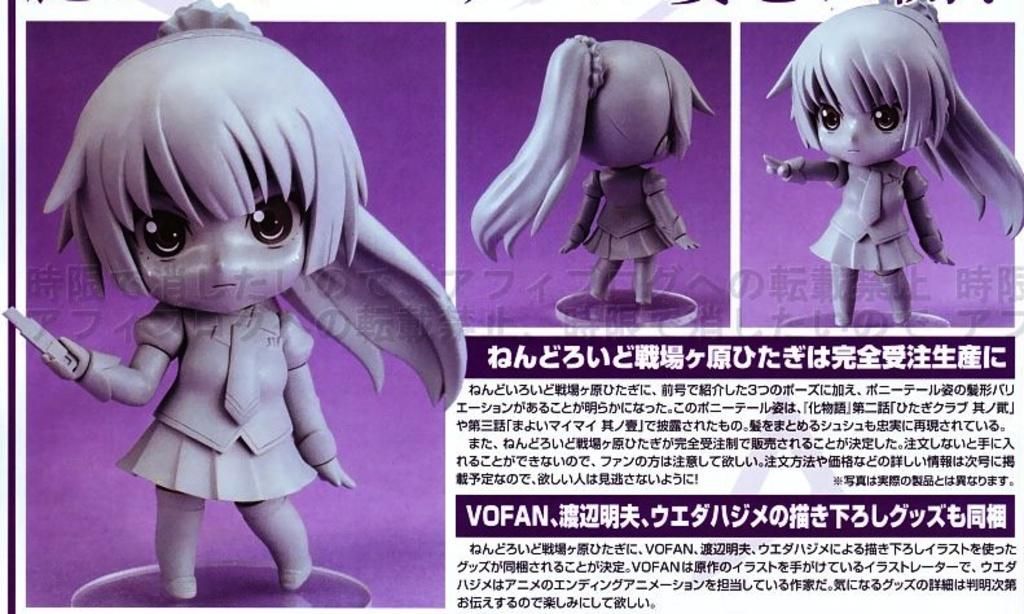What type of objects can be seen in the image? There are dolls in the image. Are there any words or letters present in the image? Yes, there is text or writing on the dolls or in the image. What is the color of the background in the image? The background color is purple. How would you describe the composition of the image? The image appears to be a collage. Can you tell me how many eyes are visible on the dolls in the image? There is no specific information about the number of eyes on the dolls in the image, as the facts provided do not mention this detail. 